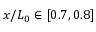Convert formula to latex. <formula><loc_0><loc_0><loc_500><loc_500>x / L _ { 0 } \in [ 0 . 7 , 0 . 8 ]</formula> 